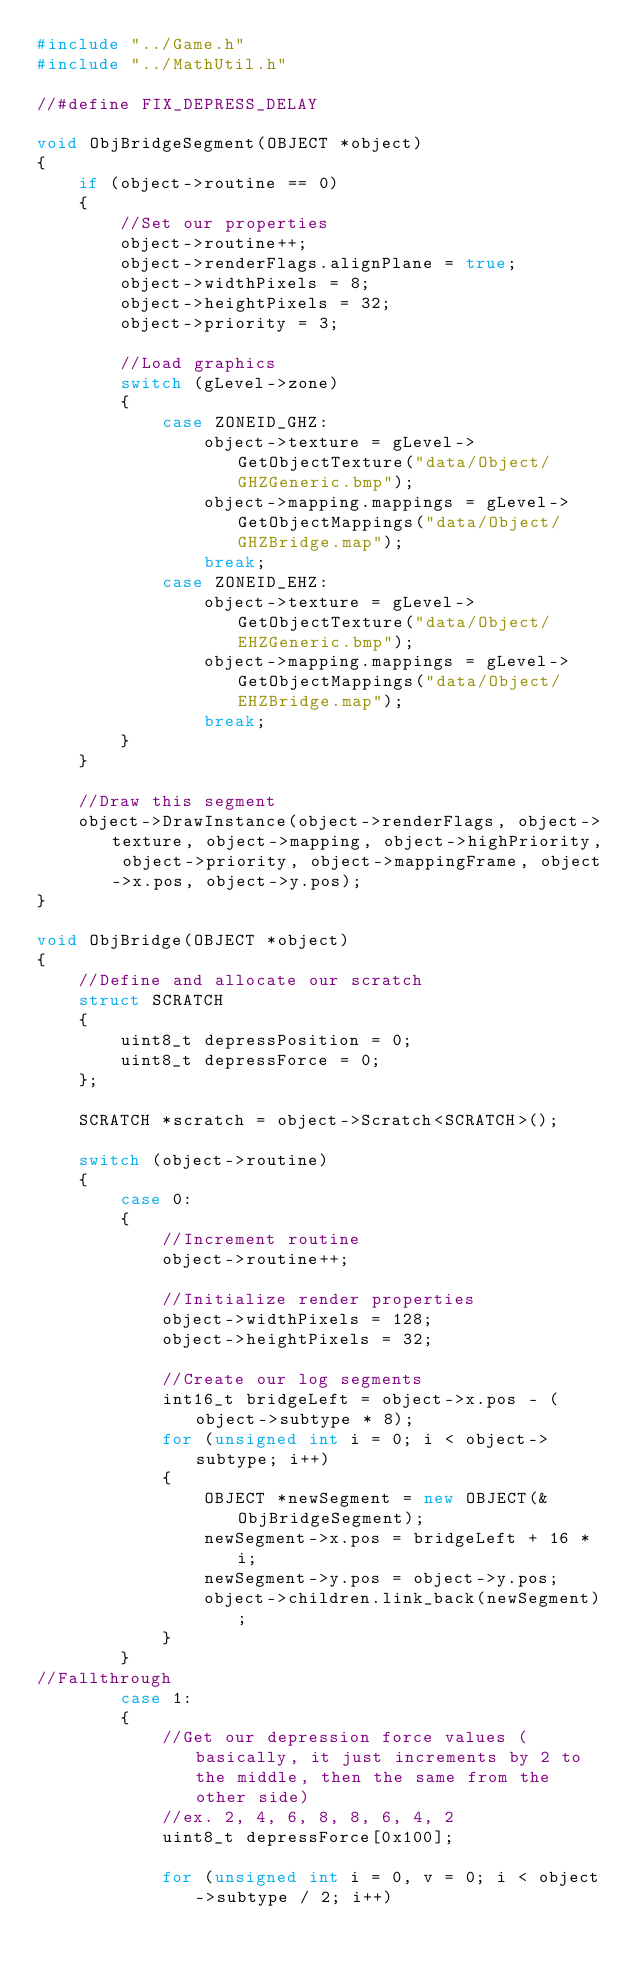<code> <loc_0><loc_0><loc_500><loc_500><_C++_>#include "../Game.h"
#include "../MathUtil.h"

//#define FIX_DEPRESS_DELAY

void ObjBridgeSegment(OBJECT *object)
{
	if (object->routine == 0)
	{
		//Set our properties
		object->routine++;
		object->renderFlags.alignPlane = true;
		object->widthPixels = 8;
		object->heightPixels = 32;
		object->priority = 3;
		
		//Load graphics
		switch (gLevel->zone)
		{
			case ZONEID_GHZ:
				object->texture = gLevel->GetObjectTexture("data/Object/GHZGeneric.bmp");
				object->mapping.mappings = gLevel->GetObjectMappings("data/Object/GHZBridge.map");
				break;
			case ZONEID_EHZ:
				object->texture = gLevel->GetObjectTexture("data/Object/EHZGeneric.bmp");
				object->mapping.mappings = gLevel->GetObjectMappings("data/Object/EHZBridge.map");
				break;
		}
	}
	
	//Draw this segment
	object->DrawInstance(object->renderFlags, object->texture, object->mapping, object->highPriority, object->priority, object->mappingFrame, object->x.pos, object->y.pos);
}

void ObjBridge(OBJECT *object)
{
	//Define and allocate our scratch
	struct SCRATCH
	{
		uint8_t depressPosition = 0;
		uint8_t depressForce = 0;
	};
	
	SCRATCH *scratch = object->Scratch<SCRATCH>();
	
	switch (object->routine)
	{
		case 0:
		{
			//Increment routine
			object->routine++;
			
			//Initialize render properties
			object->widthPixels = 128;
			object->heightPixels = 32;
			
			//Create our log segments
			int16_t bridgeLeft = object->x.pos - (object->subtype * 8);
			for (unsigned int i = 0; i < object->subtype; i++)
			{
				OBJECT *newSegment = new OBJECT(&ObjBridgeSegment);
				newSegment->x.pos = bridgeLeft + 16 * i;
				newSegment->y.pos = object->y.pos;
				object->children.link_back(newSegment);
			}
		}
//Fallthrough
		case 1:
		{
			//Get our depression force values (basically, it just increments by 2 to the middle, then the same from the other side)
			//ex. 2, 4, 6, 8, 8, 6, 4, 2
			uint8_t depressForce[0x100];
			
			for (unsigned int i = 0, v = 0; i < object->subtype / 2; i++)</code> 